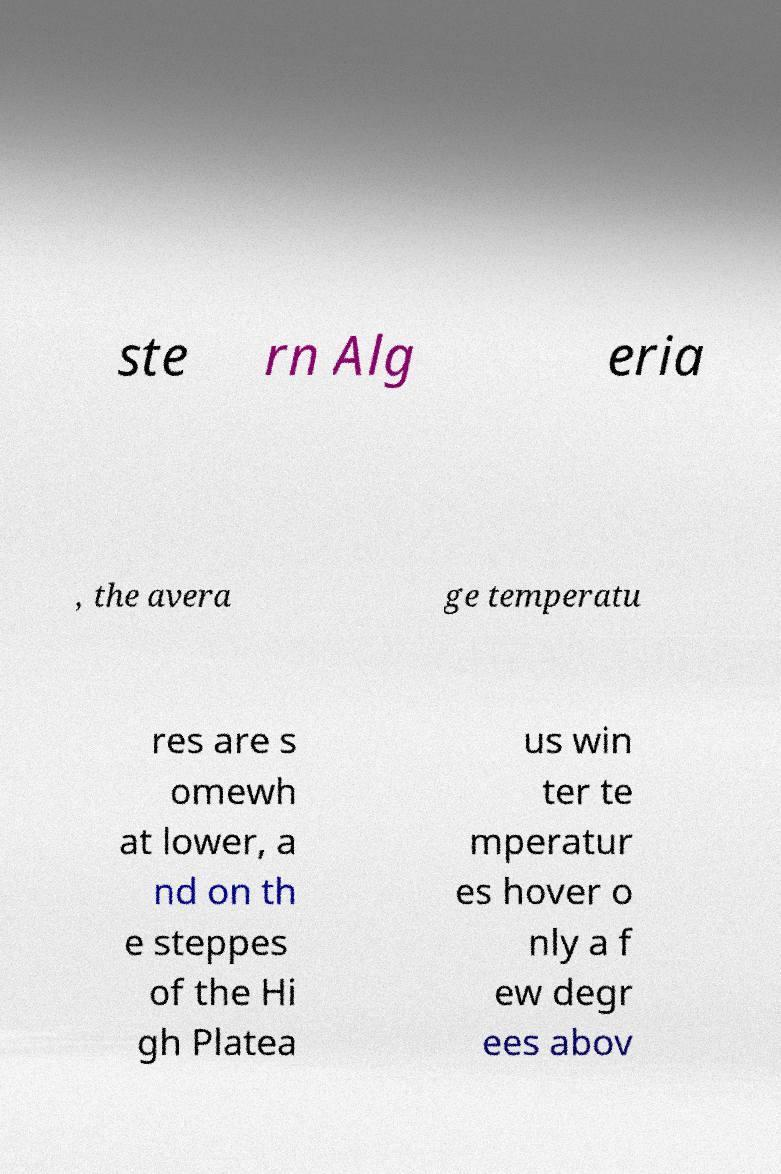Could you extract and type out the text from this image? ste rn Alg eria , the avera ge temperatu res are s omewh at lower, a nd on th e steppes of the Hi gh Platea us win ter te mperatur es hover o nly a f ew degr ees abov 